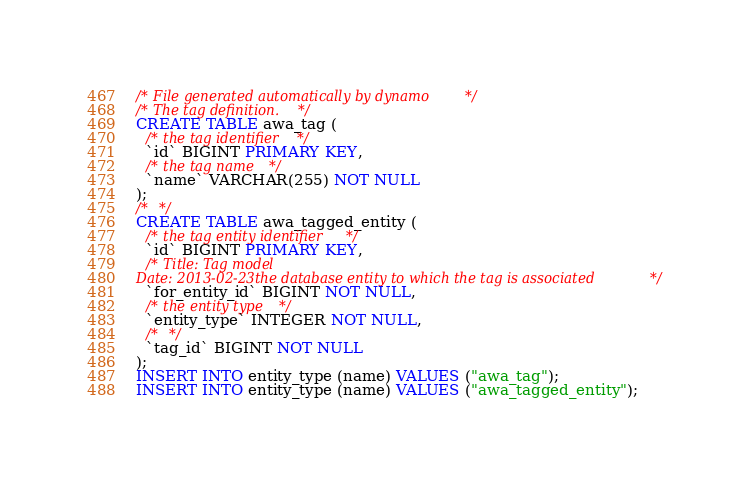<code> <loc_0><loc_0><loc_500><loc_500><_SQL_>/* File generated automatically by dynamo */
/* The tag definition. */
CREATE TABLE awa_tag (
  /* the tag identifier */
  `id` BIGINT PRIMARY KEY,
  /* the tag name */
  `name` VARCHAR(255) NOT NULL
);
/*  */
CREATE TABLE awa_tagged_entity (
  /* the tag entity identifier */
  `id` BIGINT PRIMARY KEY,
  /* Title: Tag model
Date: 2013-02-23the database entity to which the tag is associated */
  `for_entity_id` BIGINT NOT NULL,
  /* the entity type */
  `entity_type` INTEGER NOT NULL,
  /*  */
  `tag_id` BIGINT NOT NULL
);
INSERT INTO entity_type (name) VALUES ("awa_tag");
INSERT INTO entity_type (name) VALUES ("awa_tagged_entity");
</code> 